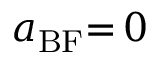Convert formula to latex. <formula><loc_0><loc_0><loc_500><loc_500>a _ { B F } { = } \, 0</formula> 